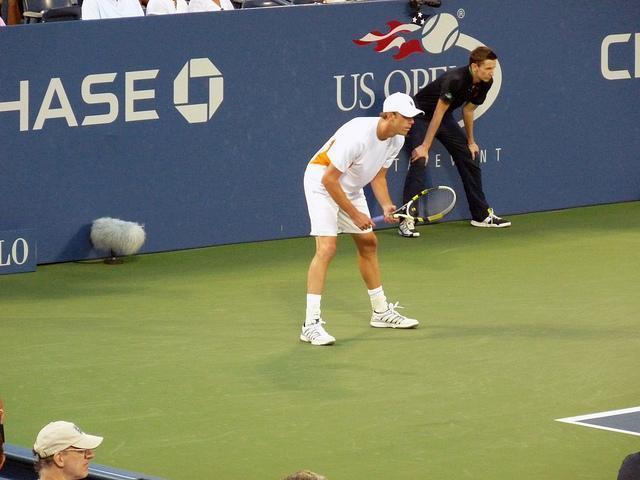What is the purpose of the white furry object?
Choose the right answer and clarify with the format: 'Answer: answer
Rationale: rationale.'
Options: Zoom in, amplify sound, hold balls, soften landing. Answer: amplify sound.
Rationale: The object helps carry sound further. 